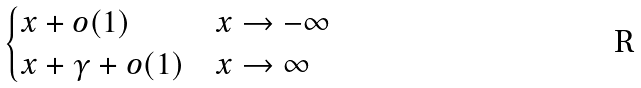<formula> <loc_0><loc_0><loc_500><loc_500>\begin{cases} x + o ( 1 ) & x \to - \infty \\ x + \gamma + o ( 1 ) & x \to \infty \end{cases}</formula> 